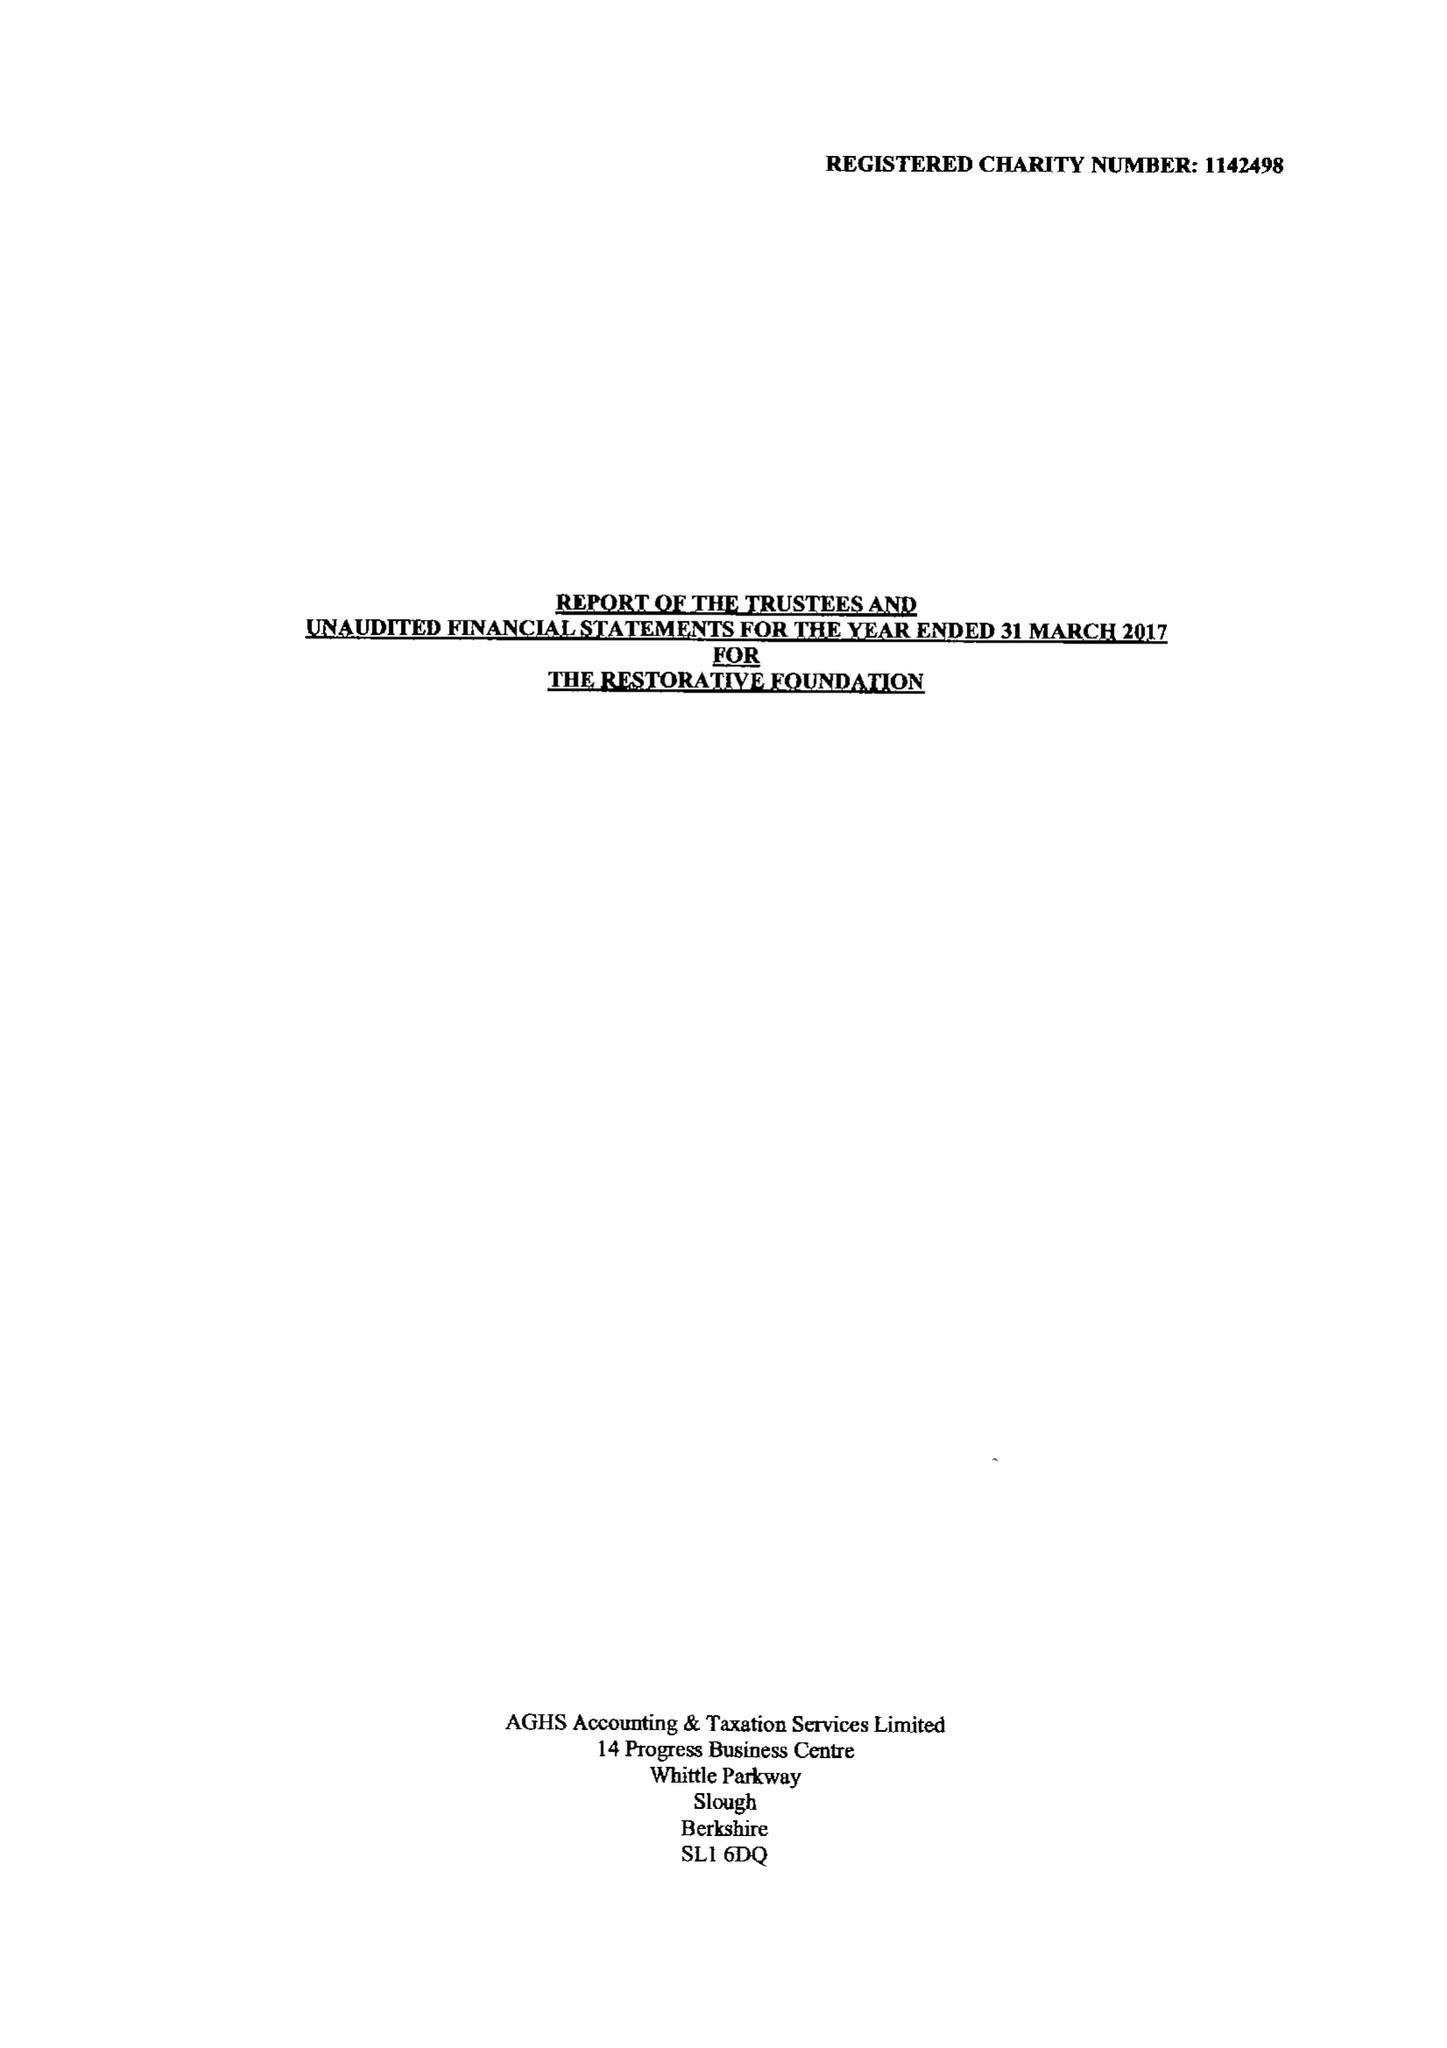What is the value for the report_date?
Answer the question using a single word or phrase. 2017-03-31 